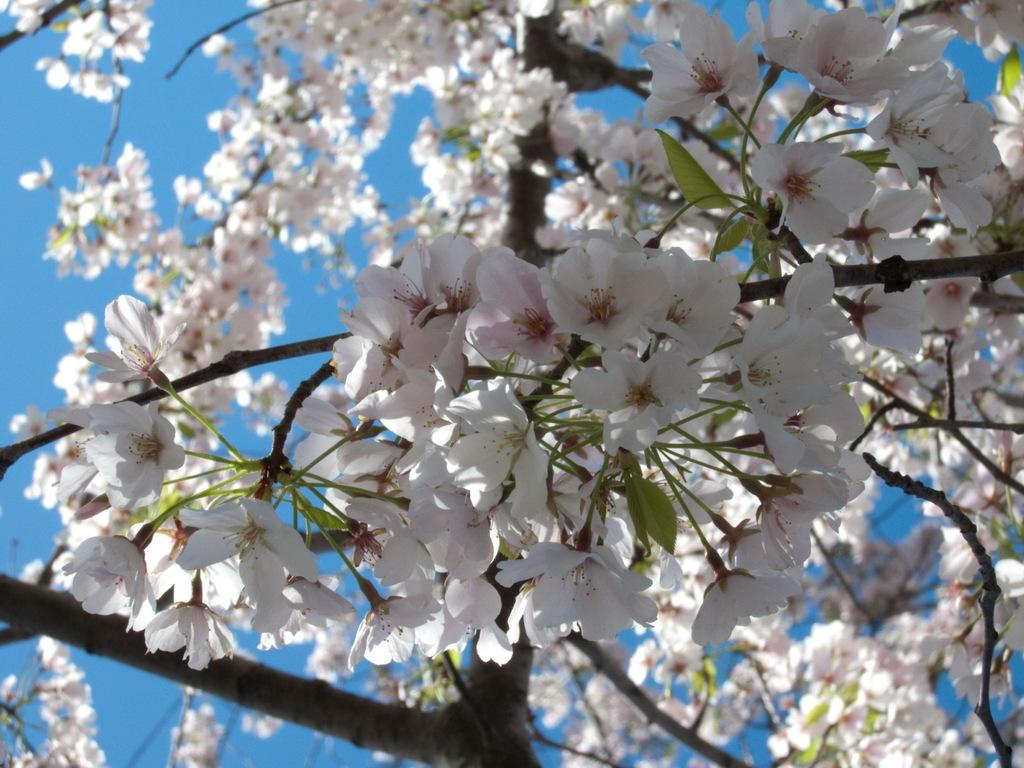What type of plant is in the picture? There is a plant in the picture, but the specific type is not mentioned. What can be seen on the plant? There are bunches of white flowers on the plant. What is visible in the background of the picture? The sky is visible in the picture. What is the color of the sky in the picture? The sky is blue in color. What type of acoustics can be heard coming from the plant in the image? There is no mention of any sounds or acoustics in the image, as it features a plant with white flowers and a blue sky. 